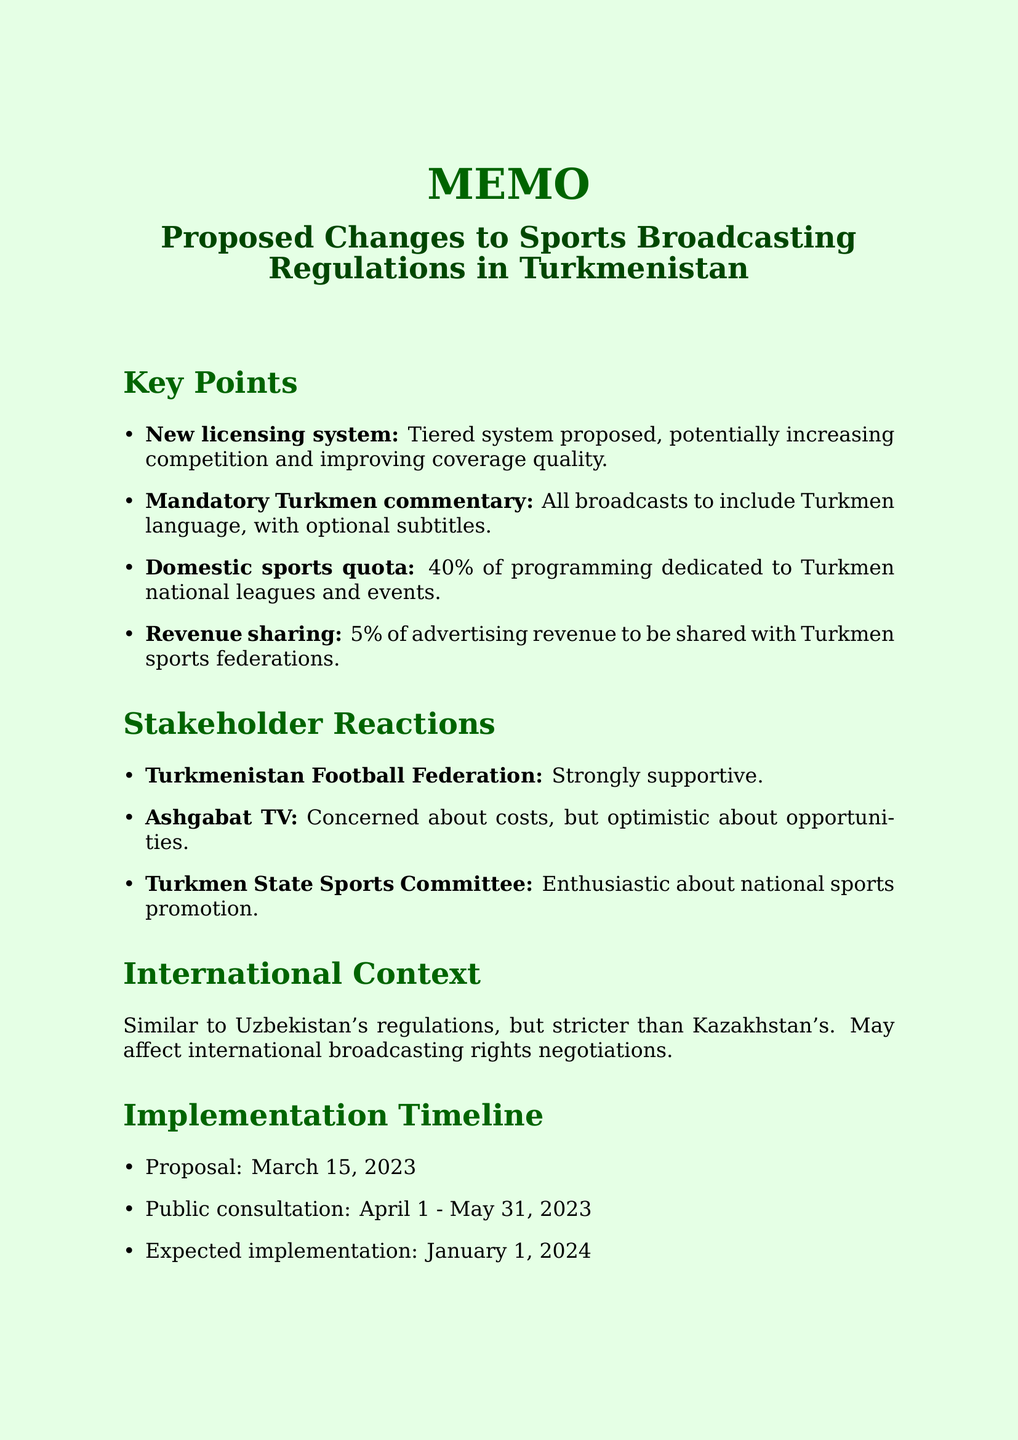what is the title of the memo? The title of the memo is presented at the top of the document, which summarizes the content and focus.
Answer: Proposed Changes to Sports Broadcasting Regulations in Turkmenistan what is the proposed implementation date? The document specifies when the proposed changes are expected to take effect.
Answer: January 1, 2024 what percentage of programming must be dedicated to domestic sports? The document states the quota requirement for sports programming allocation.
Answer: 40% who made a quote regarding the proposed changes? The memo includes a quote from a specific expert on the subject matter.
Answer: Gurbangeldi Orazov what is the revenue sharing percentage with sports federations? The document details the revenue model involving sports federations and broadcasters.
Answer: 5% how long was the public consultation period? The memo provides the dates during which public comments could be submitted about the proposal.
Answer: April 1 - May 31, 2023 what is the reaction of the Turkmenistan Football Federation? The document records reactions from key stakeholders regarding the proposed changes.
Answer: Strongly supportive how do the proposed regulations compare to Uzbekistan's regulations? The document mentions how the proposed regulations relate to those in neighboring countries.
Answer: Similar to Uzbekistan, but more stringent than Kazakhstan's approach 